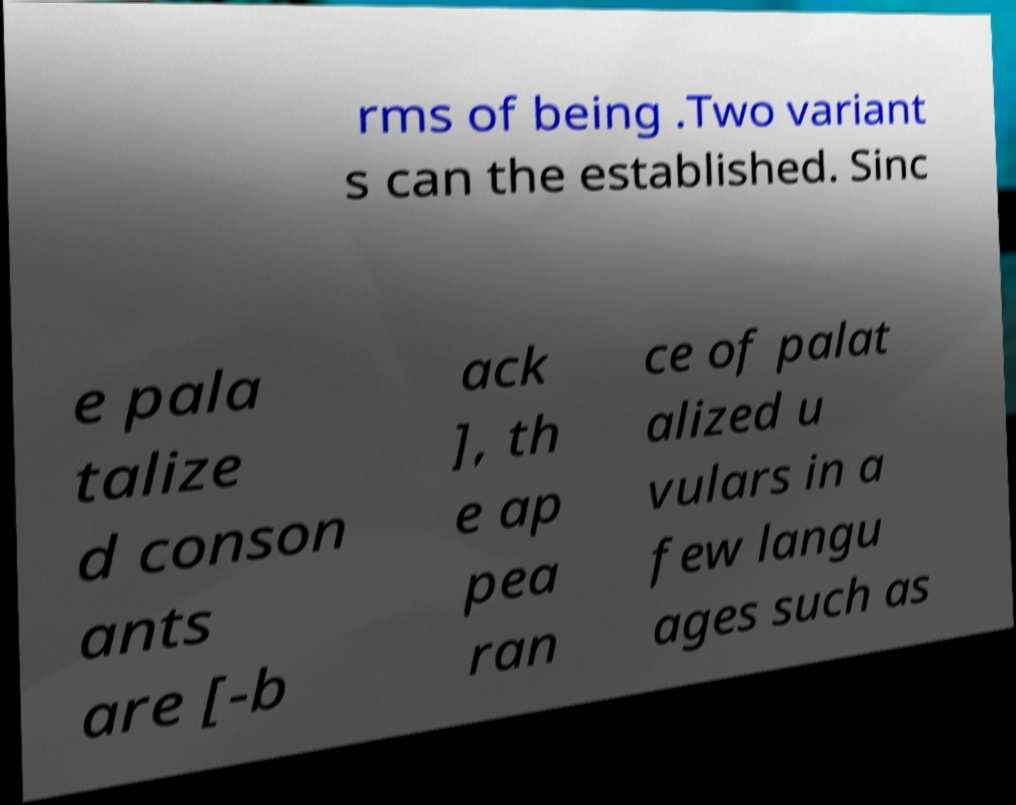For documentation purposes, I need the text within this image transcribed. Could you provide that? rms of being .Two variant s can the established. Sinc e pala talize d conson ants are [-b ack ], th e ap pea ran ce of palat alized u vulars in a few langu ages such as 